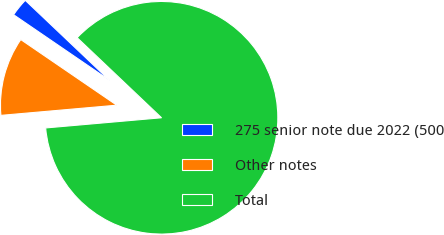Convert chart to OTSL. <chart><loc_0><loc_0><loc_500><loc_500><pie_chart><fcel>275 senior note due 2022 (500<fcel>Other notes<fcel>Total<nl><fcel>2.54%<fcel>10.94%<fcel>86.52%<nl></chart> 